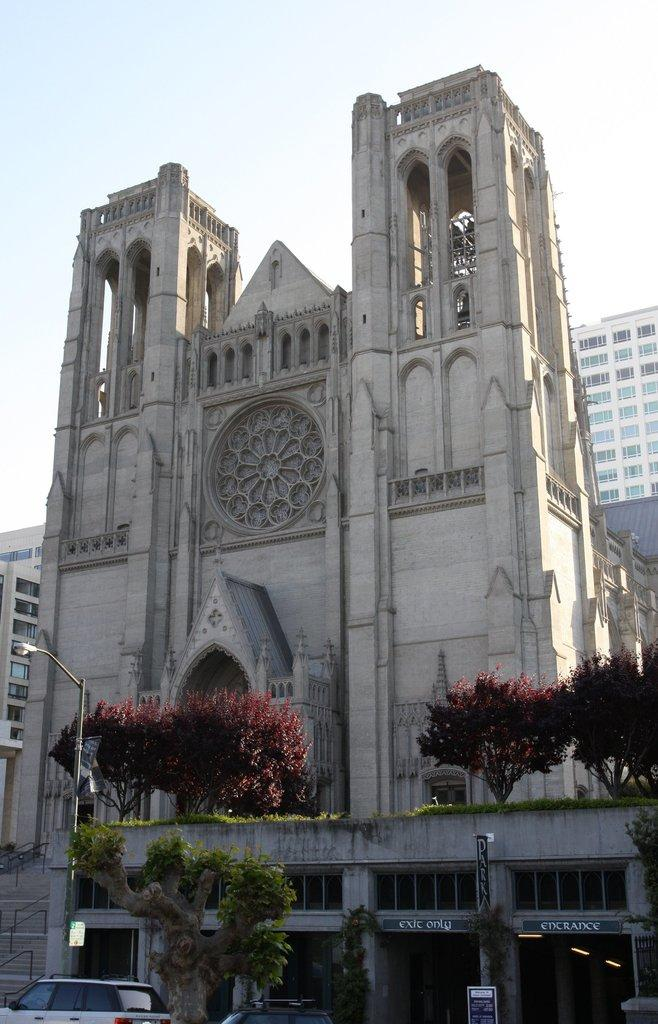What type of structures can be seen in the image? There are buildings in the image. What other natural elements are present in the image? There are trees in the image. What objects can be seen on the ground in the image? There are boards and vehicles in the image. What type of lighting is present in the image? There are lights and a light pole in the image. Are there any architectural features visible in the image? Yes, there are steps in the image. What part of the natural environment is visible in the image? The sky is visible in the image. What type of lettuce is being served at the committee meeting in the image? There is no committee meeting or lettuce present in the image. What type of pleasure can be seen being derived from the image? The image does not depict any specific pleasure or emotion; it is a scene with buildings, trees, boards, lights, a light pole, vehicles, the sky, and steps. 